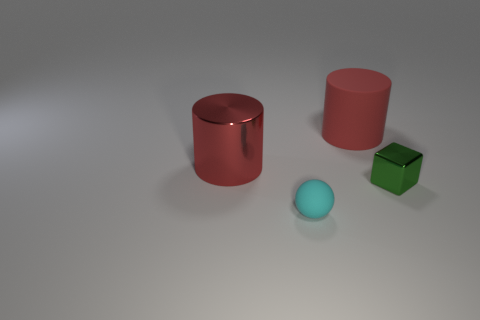Is the color of the object that is to the left of the cyan thing the same as the matte object behind the tiny metallic cube?
Provide a short and direct response. Yes. What color is the other cylinder that is the same size as the metallic cylinder?
Keep it short and to the point. Red. What number of big things are either red objects or red metallic cylinders?
Offer a very short reply. 2. There is a thing that is behind the green object and to the right of the big shiny thing; what is it made of?
Give a very brief answer. Rubber. Is the shape of the red rubber object that is behind the small rubber ball the same as the large object that is to the left of the tiny cyan sphere?
Your response must be concise. Yes. There is a object that is the same color as the matte cylinder; what is its shape?
Give a very brief answer. Cylinder. How many things are metal cubes right of the large red metal cylinder or cyan matte things?
Your answer should be very brief. 2. Is the red metal object the same size as the red rubber object?
Give a very brief answer. Yes. What is the color of the metal object that is on the left side of the big matte thing?
Offer a terse response. Red. There is a red matte thing; is its size the same as the matte object that is in front of the metal cube?
Provide a short and direct response. No. 